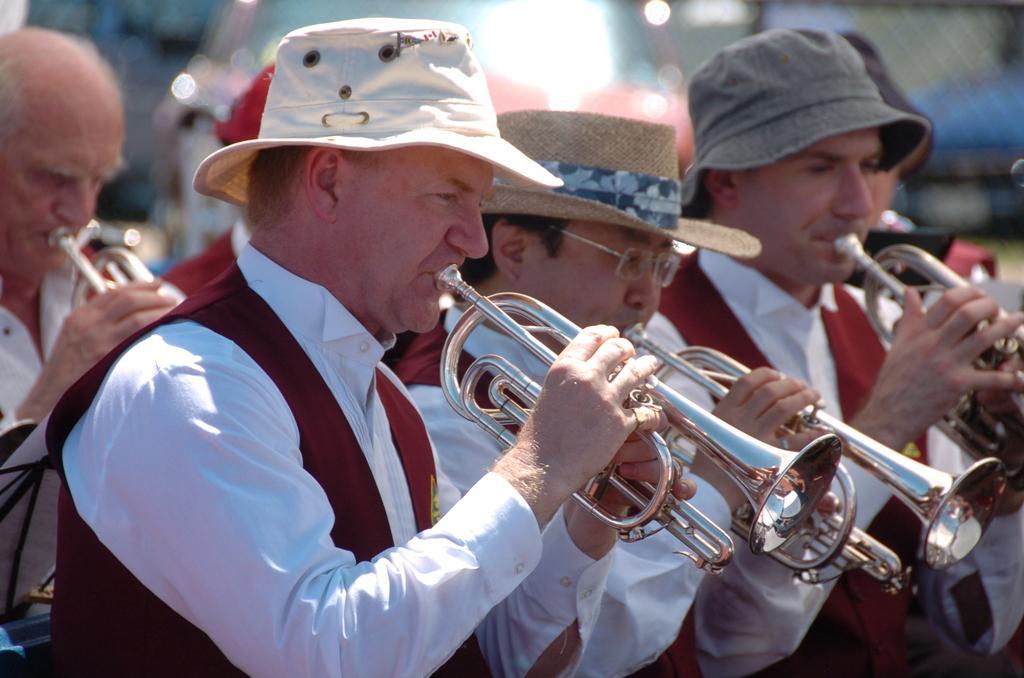In one or two sentences, can you explain what this image depicts? In this image I can see the group of people holding the trumpet. These people are wearing the white and maroon color dresses and few people with the hats. And there is a blurred background. 